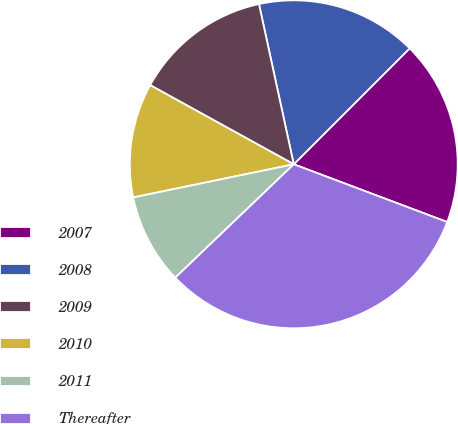Convert chart to OTSL. <chart><loc_0><loc_0><loc_500><loc_500><pie_chart><fcel>2007<fcel>2008<fcel>2009<fcel>2010<fcel>2011<fcel>Thereafter<nl><fcel>18.23%<fcel>15.9%<fcel>13.58%<fcel>11.26%<fcel>8.91%<fcel>32.12%<nl></chart> 